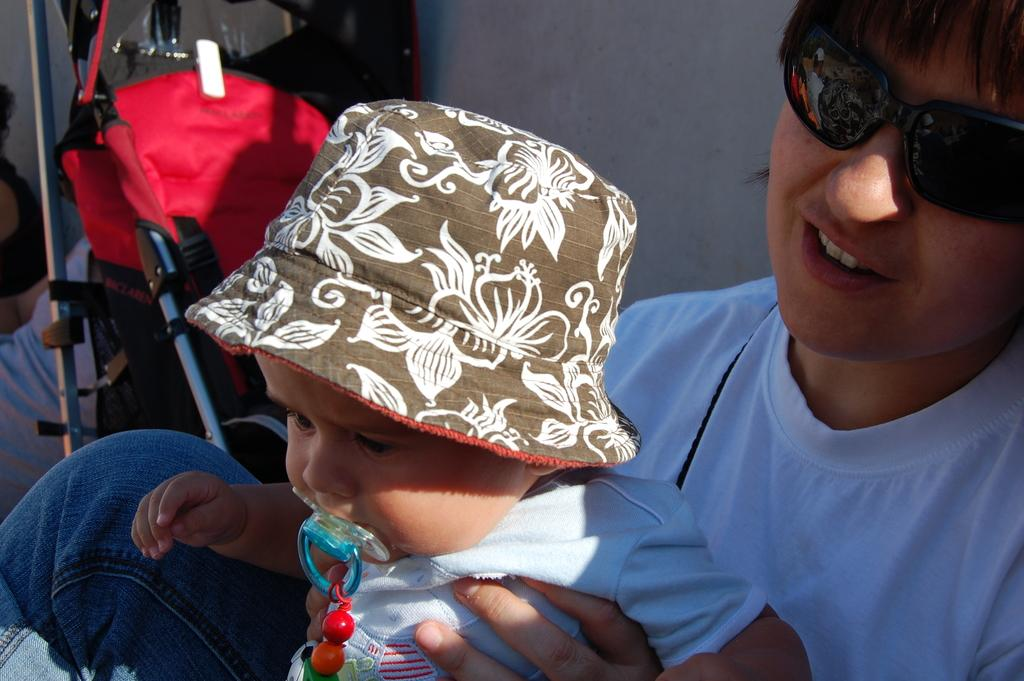What is the person on the right side of the image wearing? The person is wearing a white t-shirt. What accessory is the person wearing? The person is wearing sunglasses. What is the person's facial expression? The person is smiling. What is the person holding in the image? The person is holding a baby. What can be seen in the background of the image? There is a white wall and another person in the background of the image. What type of nerve can be seen in the image? There is no nerve visible in the image; it features a person in a white t-shirt, wearing sunglasses, and holding a baby. What kind of creature is interacting with the person in the image? There is no creature present in the image; it only features a person and a baby. 